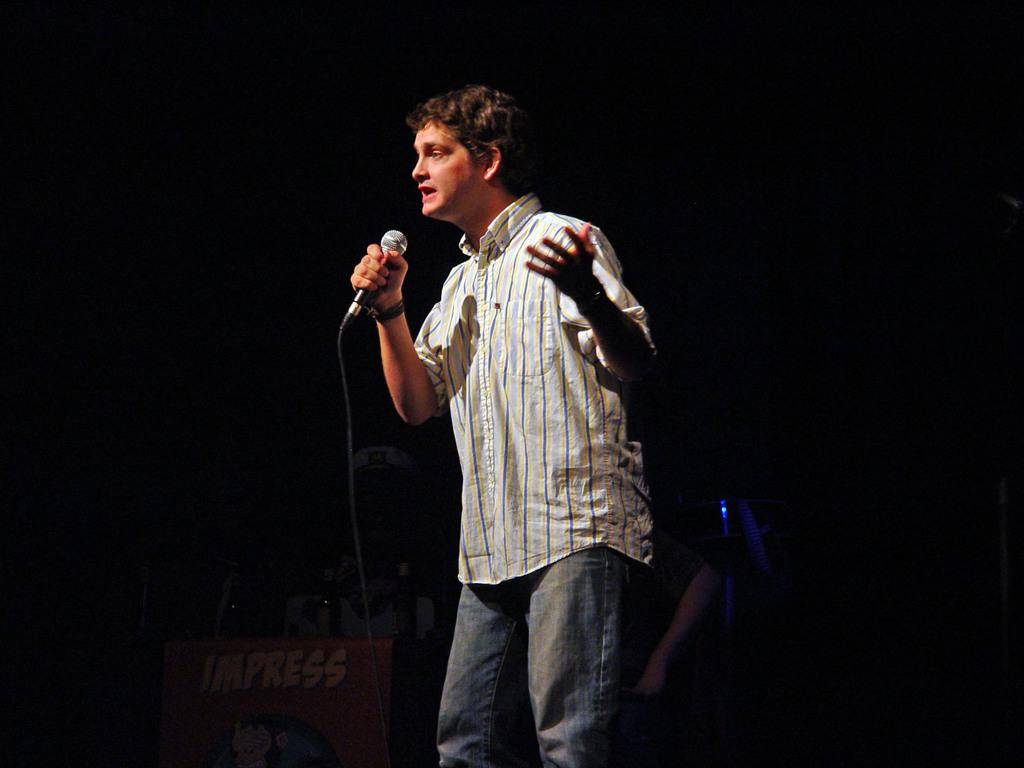Who is the main subject in the image? There is a man in the image. What is the man wearing? The man is wearing a white shirt. What is the man holding in the image? The man is holding a microphone. What is the man doing in the image? The man is singing a song. What can be seen behind the man in the image? There is a wall behind the man. What type of flesh can be seen on the man's face in the image? There is no flesh visible on the man's face in the image; it is a photograph, not a painting or drawing. 